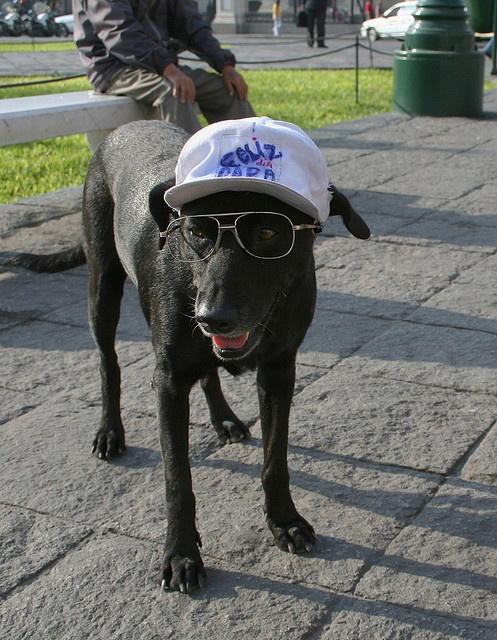Describe the objects in this image and their specific colors. I can see dog in gray, black, and darkgray tones, people in gray, black, darkgray, and maroon tones, bench in gray and lightgray tones, car in gray, white, darkgray, and lightblue tones, and motorcycle in gray, black, and purple tones in this image. 